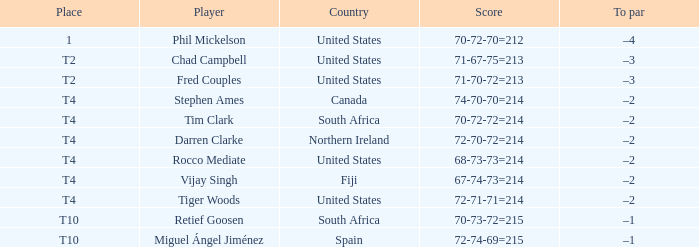What is Rocco Mediate's par? –2. 